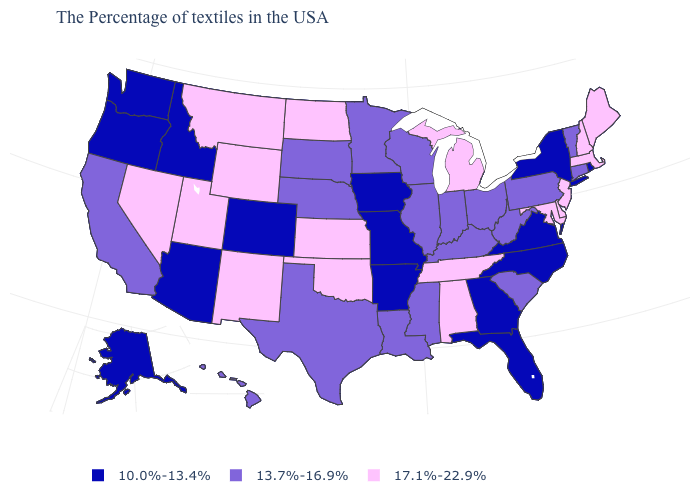Among the states that border Utah , does Nevada have the highest value?
Be succinct. Yes. What is the value of New Hampshire?
Short answer required. 17.1%-22.9%. What is the value of Ohio?
Quick response, please. 13.7%-16.9%. What is the value of Alaska?
Give a very brief answer. 10.0%-13.4%. What is the value of North Dakota?
Concise answer only. 17.1%-22.9%. Name the states that have a value in the range 17.1%-22.9%?
Keep it brief. Maine, Massachusetts, New Hampshire, New Jersey, Delaware, Maryland, Michigan, Alabama, Tennessee, Kansas, Oklahoma, North Dakota, Wyoming, New Mexico, Utah, Montana, Nevada. Among the states that border California , does Nevada have the highest value?
Short answer required. Yes. What is the highest value in the MidWest ?
Quick response, please. 17.1%-22.9%. What is the value of North Carolina?
Keep it brief. 10.0%-13.4%. What is the highest value in states that border New Mexico?
Short answer required. 17.1%-22.9%. What is the value of Oregon?
Concise answer only. 10.0%-13.4%. Among the states that border Montana , does Idaho have the highest value?
Keep it brief. No. Name the states that have a value in the range 10.0%-13.4%?
Answer briefly. Rhode Island, New York, Virginia, North Carolina, Florida, Georgia, Missouri, Arkansas, Iowa, Colorado, Arizona, Idaho, Washington, Oregon, Alaska. Does Florida have the lowest value in the USA?
Write a very short answer. Yes. Name the states that have a value in the range 13.7%-16.9%?
Short answer required. Vermont, Connecticut, Pennsylvania, South Carolina, West Virginia, Ohio, Kentucky, Indiana, Wisconsin, Illinois, Mississippi, Louisiana, Minnesota, Nebraska, Texas, South Dakota, California, Hawaii. 